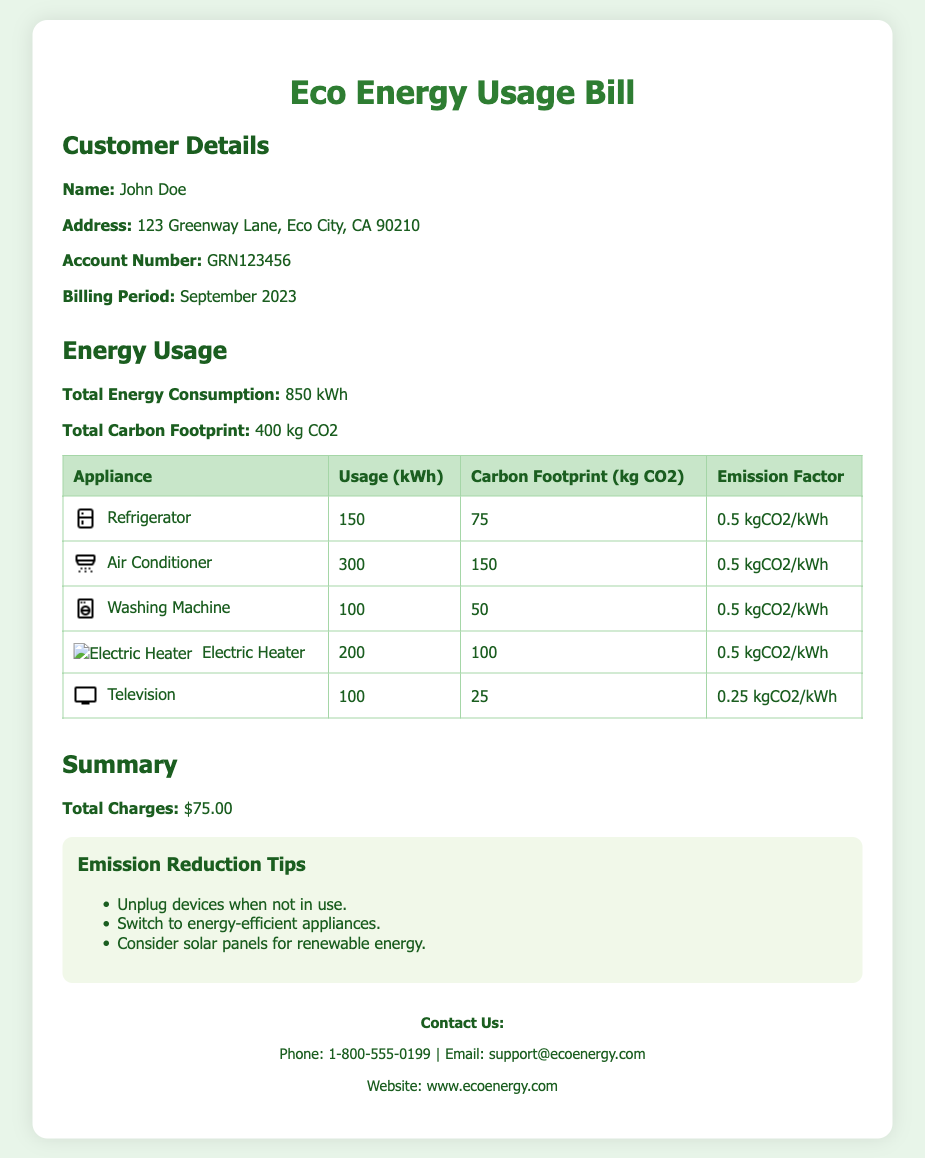What is the total energy consumption? The total energy consumption is stated in the document and reflects the energy used during the billing period.
Answer: 850 kWh What is the total carbon footprint? The document specifies the total carbon footprint resulting from energy usage over the specified period.
Answer: 400 kg CO2 How much energy does the air conditioner use? The document provides specific energy usage data for each appliance, including the air conditioner.
Answer: 300 kWh What is the emission factor for the television? The emission factor is detailed for each appliance, showing the amount of CO2 produced per kWh used by the television.
Answer: 0.25 kgCO2/kWh How much is the total charge? The total charge is summarized at the end of the document.
Answer: $75.00 What appliance has the highest carbon footprint? By comparing the carbon footprints listed for all appliances, we can identify which has the highest impact.
Answer: Air Conditioner What is one tip for emission reduction mentioned? The document lists several tips aimed at reducing emissions, providing practical advice to consumers.
Answer: Unplug devices when not in use Who is the customer? The document states the name of the customer for billing purposes.
Answer: John Doe What is the billing period? The document outlines the specific billing period for which the energy usage is calculated.
Answer: September 2023 